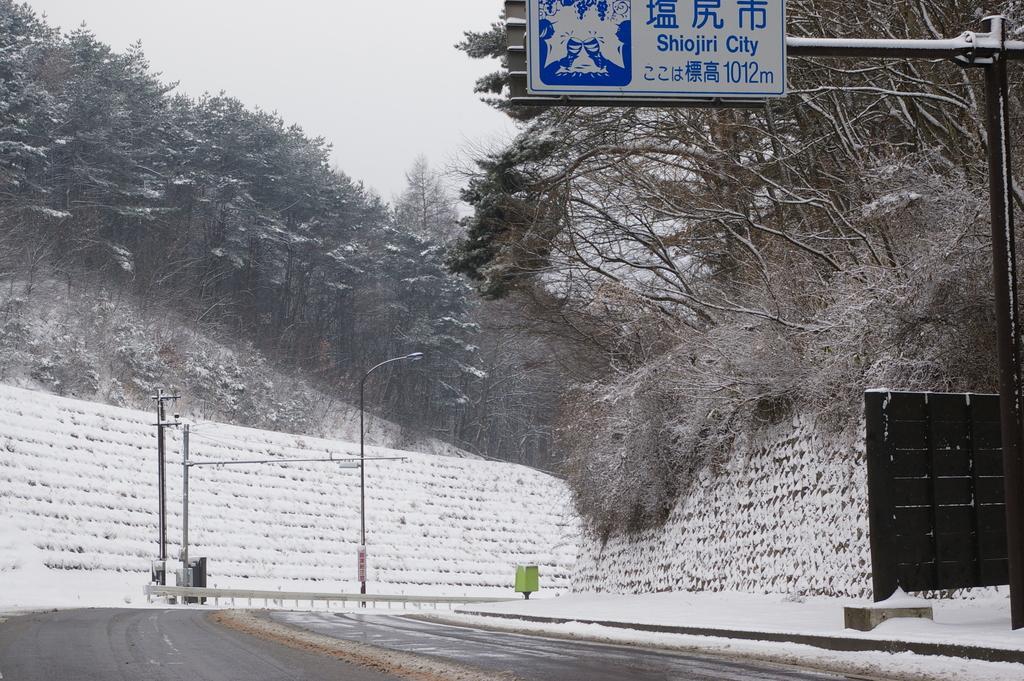In one or two sentences, can you explain what this image depicts? In this image in the center there are poles and in the background there are trees. In the front on the top there is a board with some text written on it. 